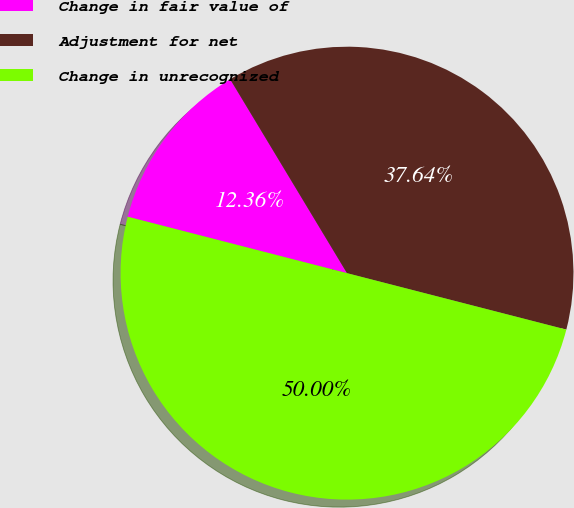Convert chart to OTSL. <chart><loc_0><loc_0><loc_500><loc_500><pie_chart><fcel>Change in fair value of<fcel>Adjustment for net<fcel>Change in unrecognized<nl><fcel>12.36%<fcel>37.64%<fcel>50.0%<nl></chart> 